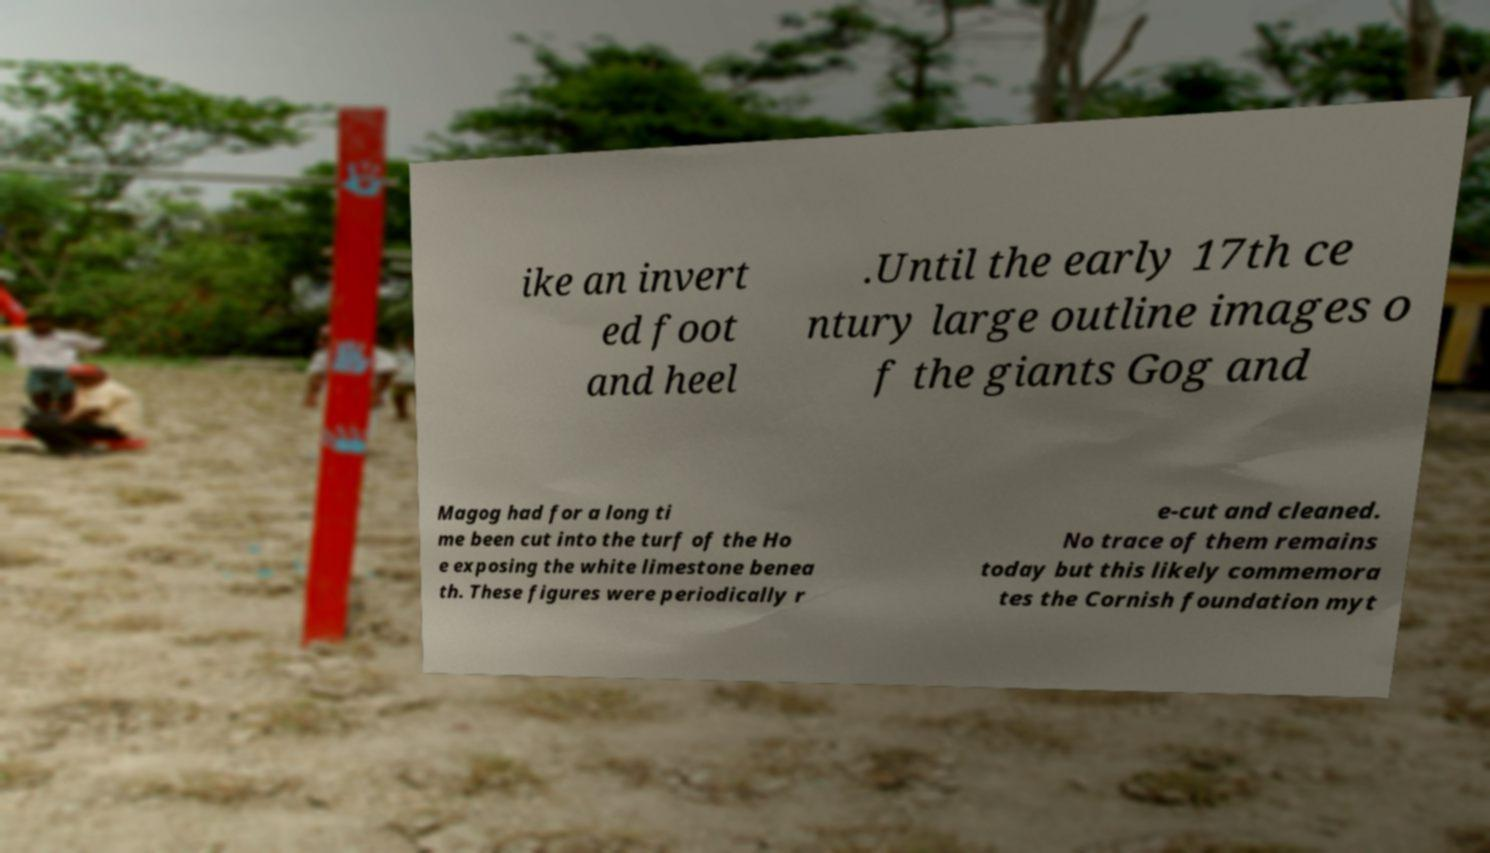Can you accurately transcribe the text from the provided image for me? ike an invert ed foot and heel .Until the early 17th ce ntury large outline images o f the giants Gog and Magog had for a long ti me been cut into the turf of the Ho e exposing the white limestone benea th. These figures were periodically r e-cut and cleaned. No trace of them remains today but this likely commemora tes the Cornish foundation myt 